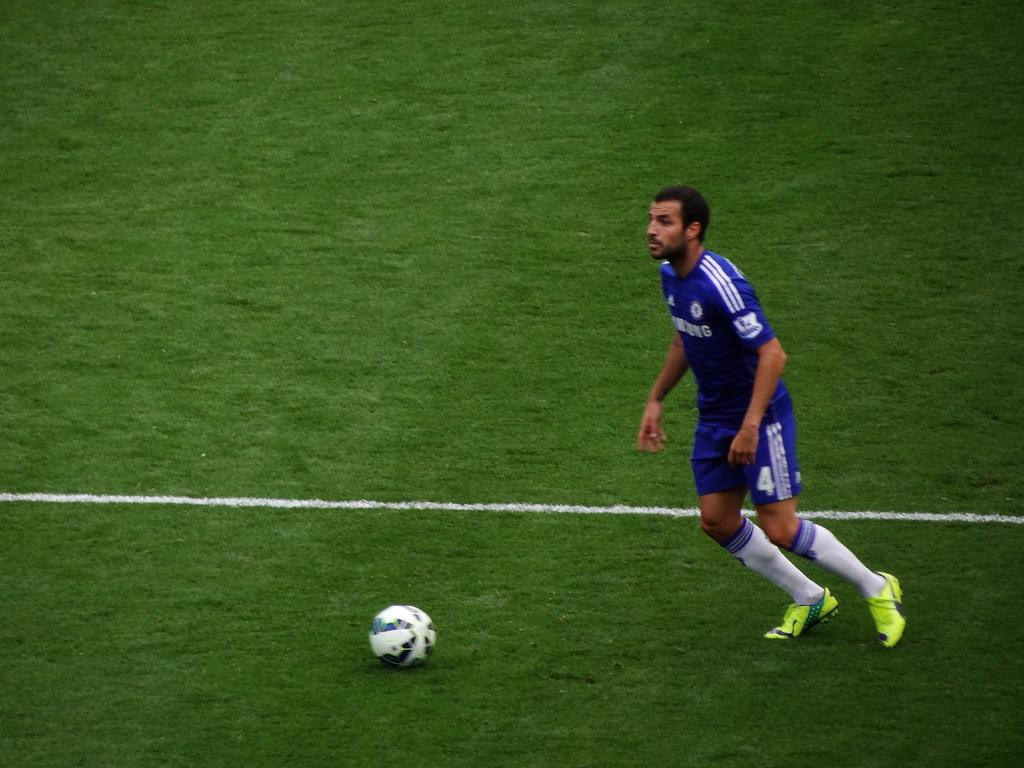What is the player's number?
Give a very brief answer. 4. 